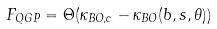Convert formula to latex. <formula><loc_0><loc_0><loc_500><loc_500>F _ { Q G P } = \Theta ( \kappa _ { B O , c } - \kappa _ { B O } ( b , s , \theta ) )</formula> 